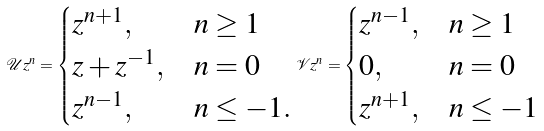Convert formula to latex. <formula><loc_0><loc_0><loc_500><loc_500>\mathcal { U } z ^ { n } = \begin{cases} z ^ { n + 1 } , & n \geq 1 \\ z + z ^ { - 1 } , & n = 0 \\ z ^ { n - 1 } , & n \leq - 1 . \end{cases} \mathcal { V } z ^ { n } = \begin{cases} z ^ { n - 1 } , & n \geq 1 \\ 0 , & n = 0 \\ z ^ { n + 1 } , & n \leq - 1 \end{cases}</formula> 